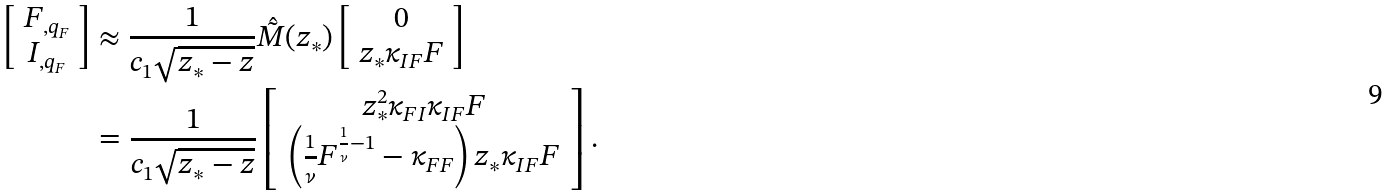Convert formula to latex. <formula><loc_0><loc_0><loc_500><loc_500>\left [ \begin{array} { c } F _ { , q _ { F } } \\ I _ { , q _ { F } } \end{array} \right ] & \approx \frac { 1 } { c _ { 1 } \sqrt { z _ { * } - z } } \hat { \tilde { M } } ( z _ { * } ) \left [ \begin{array} { c } 0 \\ z _ { * } \kappa _ { I F } F \end{array} \right ] \\ & = \frac { 1 } { c _ { 1 } \sqrt { z _ { * } - z } } \left [ \begin{array} { c } z _ { * } ^ { 2 } \kappa _ { F I } \kappa _ { I F } F \\ \left ( \frac { 1 } { \nu } F ^ { \frac { 1 } { \nu } - 1 } - \kappa _ { F F } \right ) z _ { * } \kappa _ { I F } F \end{array} \right ] .</formula> 